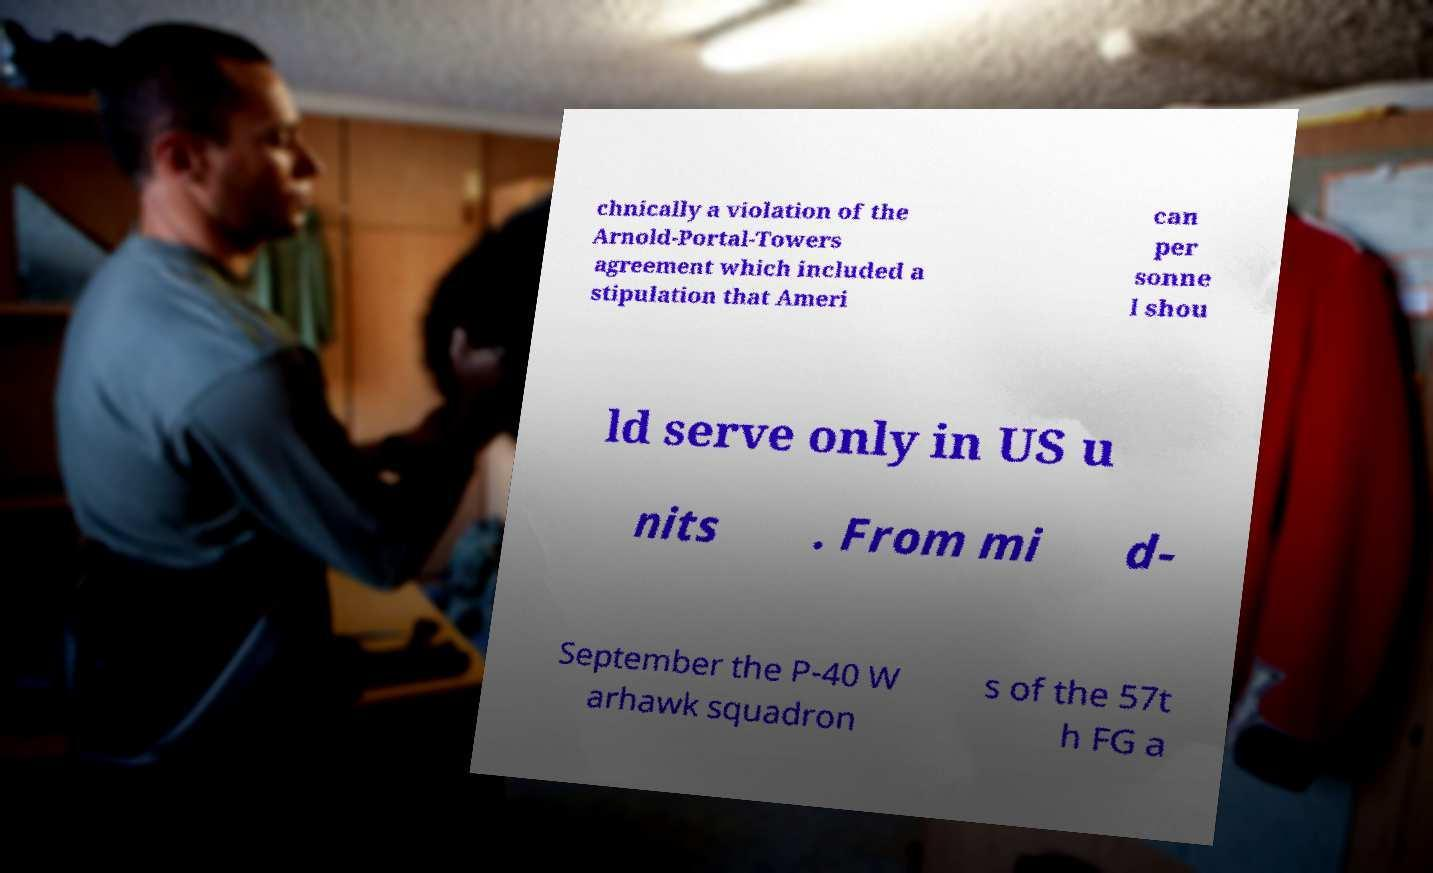For documentation purposes, I need the text within this image transcribed. Could you provide that? chnically a violation of the Arnold-Portal-Towers agreement which included a stipulation that Ameri can per sonne l shou ld serve only in US u nits . From mi d- September the P-40 W arhawk squadron s of the 57t h FG a 